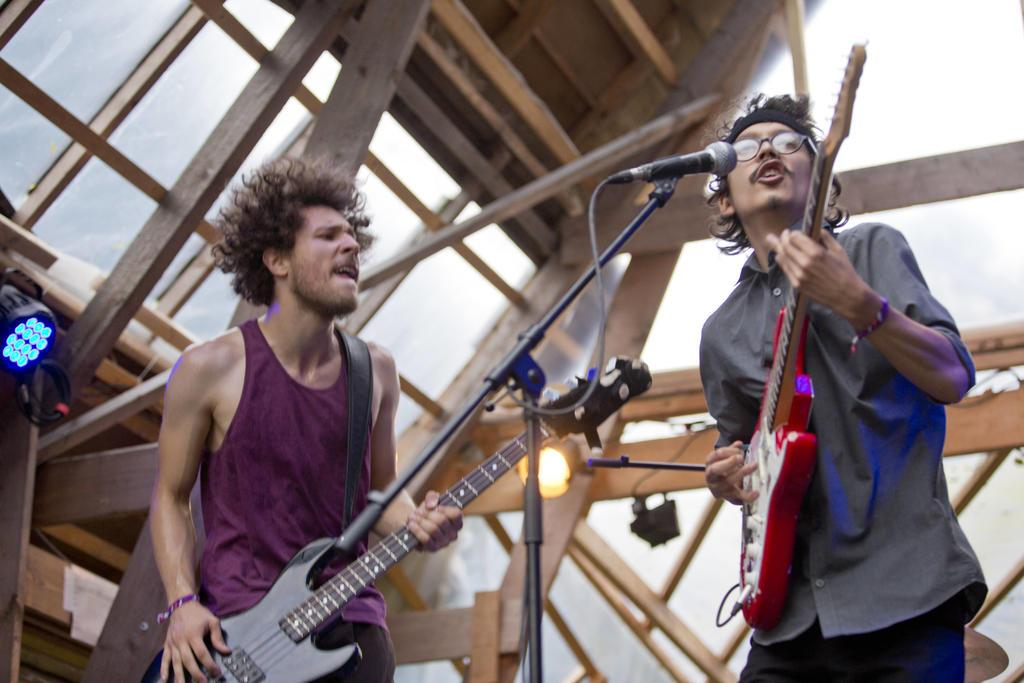How many people are in the image? There are two persons in the image. What are the persons doing in the image? The persons are standing and playing a guitar. What can be seen in the background of the image? There is light and a building in the background of the image. How many gold coins are visible on the ground in the image? There are no gold coins visible on the ground in the image. What type of birds can be seen flying in the background of the image? There are no birds visible in the image. 